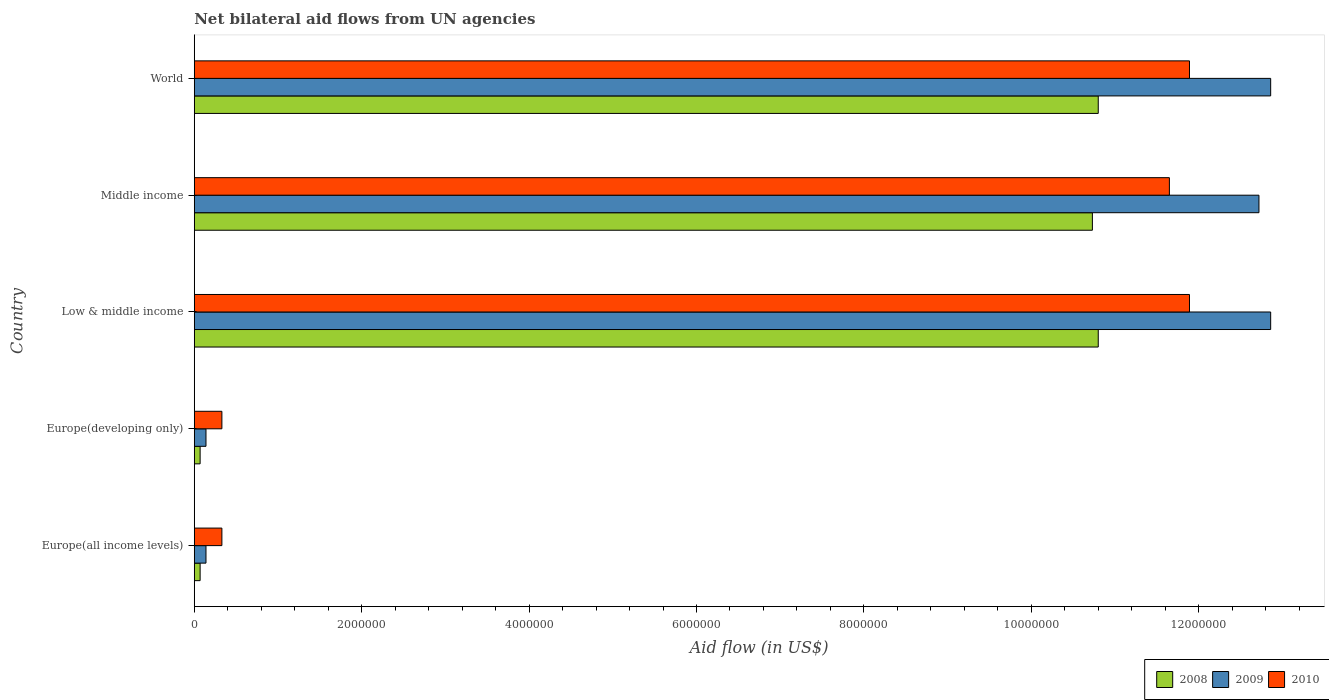How many groups of bars are there?
Offer a terse response. 5. Are the number of bars per tick equal to the number of legend labels?
Keep it short and to the point. Yes. Are the number of bars on each tick of the Y-axis equal?
Provide a succinct answer. Yes. How many bars are there on the 3rd tick from the bottom?
Provide a short and direct response. 3. What is the label of the 4th group of bars from the top?
Your answer should be very brief. Europe(developing only). What is the net bilateral aid flow in 2009 in World?
Your response must be concise. 1.29e+07. Across all countries, what is the maximum net bilateral aid flow in 2010?
Offer a very short reply. 1.19e+07. Across all countries, what is the minimum net bilateral aid flow in 2009?
Offer a terse response. 1.40e+05. In which country was the net bilateral aid flow in 2008 minimum?
Ensure brevity in your answer.  Europe(all income levels). What is the total net bilateral aid flow in 2009 in the graph?
Your response must be concise. 3.87e+07. What is the difference between the net bilateral aid flow in 2008 in Europe(all income levels) and that in Middle income?
Offer a very short reply. -1.07e+07. What is the difference between the net bilateral aid flow in 2008 in Middle income and the net bilateral aid flow in 2009 in Europe(developing only)?
Make the answer very short. 1.06e+07. What is the average net bilateral aid flow in 2010 per country?
Your answer should be compact. 7.22e+06. What is the difference between the net bilateral aid flow in 2010 and net bilateral aid flow in 2008 in World?
Your answer should be very brief. 1.09e+06. What is the ratio of the net bilateral aid flow in 2010 in Middle income to that in World?
Your response must be concise. 0.98. Is the net bilateral aid flow in 2010 in Europe(all income levels) less than that in Low & middle income?
Your answer should be very brief. Yes. Is the difference between the net bilateral aid flow in 2010 in Europe(developing only) and Low & middle income greater than the difference between the net bilateral aid flow in 2008 in Europe(developing only) and Low & middle income?
Offer a terse response. No. What is the difference between the highest and the lowest net bilateral aid flow in 2010?
Your answer should be compact. 1.16e+07. What does the 1st bar from the top in Middle income represents?
Ensure brevity in your answer.  2010. Does the graph contain any zero values?
Your answer should be very brief. No. Where does the legend appear in the graph?
Make the answer very short. Bottom right. How many legend labels are there?
Your response must be concise. 3. How are the legend labels stacked?
Your response must be concise. Horizontal. What is the title of the graph?
Offer a very short reply. Net bilateral aid flows from UN agencies. Does "1987" appear as one of the legend labels in the graph?
Keep it short and to the point. No. What is the label or title of the X-axis?
Give a very brief answer. Aid flow (in US$). What is the label or title of the Y-axis?
Your answer should be compact. Country. What is the Aid flow (in US$) in 2009 in Europe(all income levels)?
Make the answer very short. 1.40e+05. What is the Aid flow (in US$) in 2010 in Europe(all income levels)?
Make the answer very short. 3.30e+05. What is the Aid flow (in US$) in 2009 in Europe(developing only)?
Provide a succinct answer. 1.40e+05. What is the Aid flow (in US$) of 2010 in Europe(developing only)?
Make the answer very short. 3.30e+05. What is the Aid flow (in US$) of 2008 in Low & middle income?
Make the answer very short. 1.08e+07. What is the Aid flow (in US$) in 2009 in Low & middle income?
Keep it short and to the point. 1.29e+07. What is the Aid flow (in US$) of 2010 in Low & middle income?
Provide a succinct answer. 1.19e+07. What is the Aid flow (in US$) of 2008 in Middle income?
Offer a very short reply. 1.07e+07. What is the Aid flow (in US$) in 2009 in Middle income?
Ensure brevity in your answer.  1.27e+07. What is the Aid flow (in US$) in 2010 in Middle income?
Give a very brief answer. 1.16e+07. What is the Aid flow (in US$) of 2008 in World?
Offer a very short reply. 1.08e+07. What is the Aid flow (in US$) in 2009 in World?
Provide a succinct answer. 1.29e+07. What is the Aid flow (in US$) in 2010 in World?
Your answer should be compact. 1.19e+07. Across all countries, what is the maximum Aid flow (in US$) in 2008?
Offer a very short reply. 1.08e+07. Across all countries, what is the maximum Aid flow (in US$) in 2009?
Your response must be concise. 1.29e+07. Across all countries, what is the maximum Aid flow (in US$) of 2010?
Offer a terse response. 1.19e+07. Across all countries, what is the minimum Aid flow (in US$) in 2009?
Your answer should be very brief. 1.40e+05. What is the total Aid flow (in US$) of 2008 in the graph?
Offer a terse response. 3.25e+07. What is the total Aid flow (in US$) in 2009 in the graph?
Your answer should be very brief. 3.87e+07. What is the total Aid flow (in US$) in 2010 in the graph?
Give a very brief answer. 3.61e+07. What is the difference between the Aid flow (in US$) of 2008 in Europe(all income levels) and that in Europe(developing only)?
Provide a succinct answer. 0. What is the difference between the Aid flow (in US$) in 2008 in Europe(all income levels) and that in Low & middle income?
Your answer should be compact. -1.07e+07. What is the difference between the Aid flow (in US$) in 2009 in Europe(all income levels) and that in Low & middle income?
Your answer should be compact. -1.27e+07. What is the difference between the Aid flow (in US$) of 2010 in Europe(all income levels) and that in Low & middle income?
Provide a short and direct response. -1.16e+07. What is the difference between the Aid flow (in US$) in 2008 in Europe(all income levels) and that in Middle income?
Offer a terse response. -1.07e+07. What is the difference between the Aid flow (in US$) in 2009 in Europe(all income levels) and that in Middle income?
Provide a succinct answer. -1.26e+07. What is the difference between the Aid flow (in US$) of 2010 in Europe(all income levels) and that in Middle income?
Ensure brevity in your answer.  -1.13e+07. What is the difference between the Aid flow (in US$) in 2008 in Europe(all income levels) and that in World?
Ensure brevity in your answer.  -1.07e+07. What is the difference between the Aid flow (in US$) of 2009 in Europe(all income levels) and that in World?
Your answer should be very brief. -1.27e+07. What is the difference between the Aid flow (in US$) of 2010 in Europe(all income levels) and that in World?
Make the answer very short. -1.16e+07. What is the difference between the Aid flow (in US$) in 2008 in Europe(developing only) and that in Low & middle income?
Your answer should be compact. -1.07e+07. What is the difference between the Aid flow (in US$) in 2009 in Europe(developing only) and that in Low & middle income?
Make the answer very short. -1.27e+07. What is the difference between the Aid flow (in US$) of 2010 in Europe(developing only) and that in Low & middle income?
Make the answer very short. -1.16e+07. What is the difference between the Aid flow (in US$) of 2008 in Europe(developing only) and that in Middle income?
Keep it short and to the point. -1.07e+07. What is the difference between the Aid flow (in US$) in 2009 in Europe(developing only) and that in Middle income?
Your answer should be very brief. -1.26e+07. What is the difference between the Aid flow (in US$) in 2010 in Europe(developing only) and that in Middle income?
Provide a short and direct response. -1.13e+07. What is the difference between the Aid flow (in US$) in 2008 in Europe(developing only) and that in World?
Your response must be concise. -1.07e+07. What is the difference between the Aid flow (in US$) of 2009 in Europe(developing only) and that in World?
Keep it short and to the point. -1.27e+07. What is the difference between the Aid flow (in US$) of 2010 in Europe(developing only) and that in World?
Offer a very short reply. -1.16e+07. What is the difference between the Aid flow (in US$) in 2009 in Low & middle income and that in World?
Keep it short and to the point. 0. What is the difference between the Aid flow (in US$) in 2008 in Middle income and that in World?
Offer a very short reply. -7.00e+04. What is the difference between the Aid flow (in US$) of 2008 in Europe(all income levels) and the Aid flow (in US$) of 2009 in Europe(developing only)?
Your answer should be very brief. -7.00e+04. What is the difference between the Aid flow (in US$) of 2008 in Europe(all income levels) and the Aid flow (in US$) of 2010 in Europe(developing only)?
Your answer should be very brief. -2.60e+05. What is the difference between the Aid flow (in US$) in 2008 in Europe(all income levels) and the Aid flow (in US$) in 2009 in Low & middle income?
Give a very brief answer. -1.28e+07. What is the difference between the Aid flow (in US$) in 2008 in Europe(all income levels) and the Aid flow (in US$) in 2010 in Low & middle income?
Your response must be concise. -1.18e+07. What is the difference between the Aid flow (in US$) in 2009 in Europe(all income levels) and the Aid flow (in US$) in 2010 in Low & middle income?
Give a very brief answer. -1.18e+07. What is the difference between the Aid flow (in US$) in 2008 in Europe(all income levels) and the Aid flow (in US$) in 2009 in Middle income?
Your response must be concise. -1.26e+07. What is the difference between the Aid flow (in US$) of 2008 in Europe(all income levels) and the Aid flow (in US$) of 2010 in Middle income?
Provide a succinct answer. -1.16e+07. What is the difference between the Aid flow (in US$) in 2009 in Europe(all income levels) and the Aid flow (in US$) in 2010 in Middle income?
Give a very brief answer. -1.15e+07. What is the difference between the Aid flow (in US$) in 2008 in Europe(all income levels) and the Aid flow (in US$) in 2009 in World?
Your answer should be compact. -1.28e+07. What is the difference between the Aid flow (in US$) of 2008 in Europe(all income levels) and the Aid flow (in US$) of 2010 in World?
Provide a short and direct response. -1.18e+07. What is the difference between the Aid flow (in US$) of 2009 in Europe(all income levels) and the Aid flow (in US$) of 2010 in World?
Your answer should be very brief. -1.18e+07. What is the difference between the Aid flow (in US$) in 2008 in Europe(developing only) and the Aid flow (in US$) in 2009 in Low & middle income?
Provide a succinct answer. -1.28e+07. What is the difference between the Aid flow (in US$) of 2008 in Europe(developing only) and the Aid flow (in US$) of 2010 in Low & middle income?
Your response must be concise. -1.18e+07. What is the difference between the Aid flow (in US$) in 2009 in Europe(developing only) and the Aid flow (in US$) in 2010 in Low & middle income?
Offer a very short reply. -1.18e+07. What is the difference between the Aid flow (in US$) in 2008 in Europe(developing only) and the Aid flow (in US$) in 2009 in Middle income?
Make the answer very short. -1.26e+07. What is the difference between the Aid flow (in US$) in 2008 in Europe(developing only) and the Aid flow (in US$) in 2010 in Middle income?
Give a very brief answer. -1.16e+07. What is the difference between the Aid flow (in US$) in 2009 in Europe(developing only) and the Aid flow (in US$) in 2010 in Middle income?
Ensure brevity in your answer.  -1.15e+07. What is the difference between the Aid flow (in US$) of 2008 in Europe(developing only) and the Aid flow (in US$) of 2009 in World?
Offer a terse response. -1.28e+07. What is the difference between the Aid flow (in US$) of 2008 in Europe(developing only) and the Aid flow (in US$) of 2010 in World?
Ensure brevity in your answer.  -1.18e+07. What is the difference between the Aid flow (in US$) of 2009 in Europe(developing only) and the Aid flow (in US$) of 2010 in World?
Keep it short and to the point. -1.18e+07. What is the difference between the Aid flow (in US$) of 2008 in Low & middle income and the Aid flow (in US$) of 2009 in Middle income?
Offer a terse response. -1.92e+06. What is the difference between the Aid flow (in US$) in 2008 in Low & middle income and the Aid flow (in US$) in 2010 in Middle income?
Give a very brief answer. -8.50e+05. What is the difference between the Aid flow (in US$) of 2009 in Low & middle income and the Aid flow (in US$) of 2010 in Middle income?
Provide a short and direct response. 1.21e+06. What is the difference between the Aid flow (in US$) in 2008 in Low & middle income and the Aid flow (in US$) in 2009 in World?
Your response must be concise. -2.06e+06. What is the difference between the Aid flow (in US$) in 2008 in Low & middle income and the Aid flow (in US$) in 2010 in World?
Ensure brevity in your answer.  -1.09e+06. What is the difference between the Aid flow (in US$) in 2009 in Low & middle income and the Aid flow (in US$) in 2010 in World?
Your answer should be very brief. 9.70e+05. What is the difference between the Aid flow (in US$) of 2008 in Middle income and the Aid flow (in US$) of 2009 in World?
Your answer should be compact. -2.13e+06. What is the difference between the Aid flow (in US$) in 2008 in Middle income and the Aid flow (in US$) in 2010 in World?
Your response must be concise. -1.16e+06. What is the difference between the Aid flow (in US$) of 2009 in Middle income and the Aid flow (in US$) of 2010 in World?
Your answer should be very brief. 8.30e+05. What is the average Aid flow (in US$) in 2008 per country?
Give a very brief answer. 6.49e+06. What is the average Aid flow (in US$) of 2009 per country?
Offer a very short reply. 7.74e+06. What is the average Aid flow (in US$) of 2010 per country?
Offer a terse response. 7.22e+06. What is the difference between the Aid flow (in US$) in 2008 and Aid flow (in US$) in 2009 in Europe(all income levels)?
Make the answer very short. -7.00e+04. What is the difference between the Aid flow (in US$) in 2008 and Aid flow (in US$) in 2010 in Europe(all income levels)?
Offer a very short reply. -2.60e+05. What is the difference between the Aid flow (in US$) of 2008 and Aid flow (in US$) of 2009 in Europe(developing only)?
Make the answer very short. -7.00e+04. What is the difference between the Aid flow (in US$) in 2008 and Aid flow (in US$) in 2010 in Europe(developing only)?
Ensure brevity in your answer.  -2.60e+05. What is the difference between the Aid flow (in US$) in 2008 and Aid flow (in US$) in 2009 in Low & middle income?
Keep it short and to the point. -2.06e+06. What is the difference between the Aid flow (in US$) in 2008 and Aid flow (in US$) in 2010 in Low & middle income?
Your answer should be compact. -1.09e+06. What is the difference between the Aid flow (in US$) of 2009 and Aid flow (in US$) of 2010 in Low & middle income?
Your response must be concise. 9.70e+05. What is the difference between the Aid flow (in US$) of 2008 and Aid flow (in US$) of 2009 in Middle income?
Make the answer very short. -1.99e+06. What is the difference between the Aid flow (in US$) in 2008 and Aid flow (in US$) in 2010 in Middle income?
Make the answer very short. -9.20e+05. What is the difference between the Aid flow (in US$) in 2009 and Aid flow (in US$) in 2010 in Middle income?
Keep it short and to the point. 1.07e+06. What is the difference between the Aid flow (in US$) of 2008 and Aid flow (in US$) of 2009 in World?
Provide a short and direct response. -2.06e+06. What is the difference between the Aid flow (in US$) of 2008 and Aid flow (in US$) of 2010 in World?
Make the answer very short. -1.09e+06. What is the difference between the Aid flow (in US$) in 2009 and Aid flow (in US$) in 2010 in World?
Your answer should be very brief. 9.70e+05. What is the ratio of the Aid flow (in US$) of 2008 in Europe(all income levels) to that in Europe(developing only)?
Give a very brief answer. 1. What is the ratio of the Aid flow (in US$) of 2008 in Europe(all income levels) to that in Low & middle income?
Ensure brevity in your answer.  0.01. What is the ratio of the Aid flow (in US$) in 2009 in Europe(all income levels) to that in Low & middle income?
Keep it short and to the point. 0.01. What is the ratio of the Aid flow (in US$) in 2010 in Europe(all income levels) to that in Low & middle income?
Your response must be concise. 0.03. What is the ratio of the Aid flow (in US$) in 2008 in Europe(all income levels) to that in Middle income?
Keep it short and to the point. 0.01. What is the ratio of the Aid flow (in US$) in 2009 in Europe(all income levels) to that in Middle income?
Your response must be concise. 0.01. What is the ratio of the Aid flow (in US$) in 2010 in Europe(all income levels) to that in Middle income?
Your answer should be compact. 0.03. What is the ratio of the Aid flow (in US$) in 2008 in Europe(all income levels) to that in World?
Your answer should be compact. 0.01. What is the ratio of the Aid flow (in US$) of 2009 in Europe(all income levels) to that in World?
Your answer should be compact. 0.01. What is the ratio of the Aid flow (in US$) of 2010 in Europe(all income levels) to that in World?
Offer a terse response. 0.03. What is the ratio of the Aid flow (in US$) in 2008 in Europe(developing only) to that in Low & middle income?
Keep it short and to the point. 0.01. What is the ratio of the Aid flow (in US$) of 2009 in Europe(developing only) to that in Low & middle income?
Your response must be concise. 0.01. What is the ratio of the Aid flow (in US$) in 2010 in Europe(developing only) to that in Low & middle income?
Provide a succinct answer. 0.03. What is the ratio of the Aid flow (in US$) of 2008 in Europe(developing only) to that in Middle income?
Ensure brevity in your answer.  0.01. What is the ratio of the Aid flow (in US$) in 2009 in Europe(developing only) to that in Middle income?
Offer a very short reply. 0.01. What is the ratio of the Aid flow (in US$) in 2010 in Europe(developing only) to that in Middle income?
Your response must be concise. 0.03. What is the ratio of the Aid flow (in US$) of 2008 in Europe(developing only) to that in World?
Provide a succinct answer. 0.01. What is the ratio of the Aid flow (in US$) of 2009 in Europe(developing only) to that in World?
Your answer should be very brief. 0.01. What is the ratio of the Aid flow (in US$) of 2010 in Europe(developing only) to that in World?
Make the answer very short. 0.03. What is the ratio of the Aid flow (in US$) of 2010 in Low & middle income to that in Middle income?
Provide a short and direct response. 1.02. What is the ratio of the Aid flow (in US$) of 2008 in Low & middle income to that in World?
Your response must be concise. 1. What is the ratio of the Aid flow (in US$) in 2009 in Low & middle income to that in World?
Provide a succinct answer. 1. What is the ratio of the Aid flow (in US$) in 2010 in Low & middle income to that in World?
Your answer should be very brief. 1. What is the ratio of the Aid flow (in US$) in 2010 in Middle income to that in World?
Provide a short and direct response. 0.98. What is the difference between the highest and the second highest Aid flow (in US$) of 2009?
Make the answer very short. 0. What is the difference between the highest and the second highest Aid flow (in US$) of 2010?
Your answer should be compact. 0. What is the difference between the highest and the lowest Aid flow (in US$) of 2008?
Give a very brief answer. 1.07e+07. What is the difference between the highest and the lowest Aid flow (in US$) of 2009?
Provide a short and direct response. 1.27e+07. What is the difference between the highest and the lowest Aid flow (in US$) of 2010?
Provide a succinct answer. 1.16e+07. 